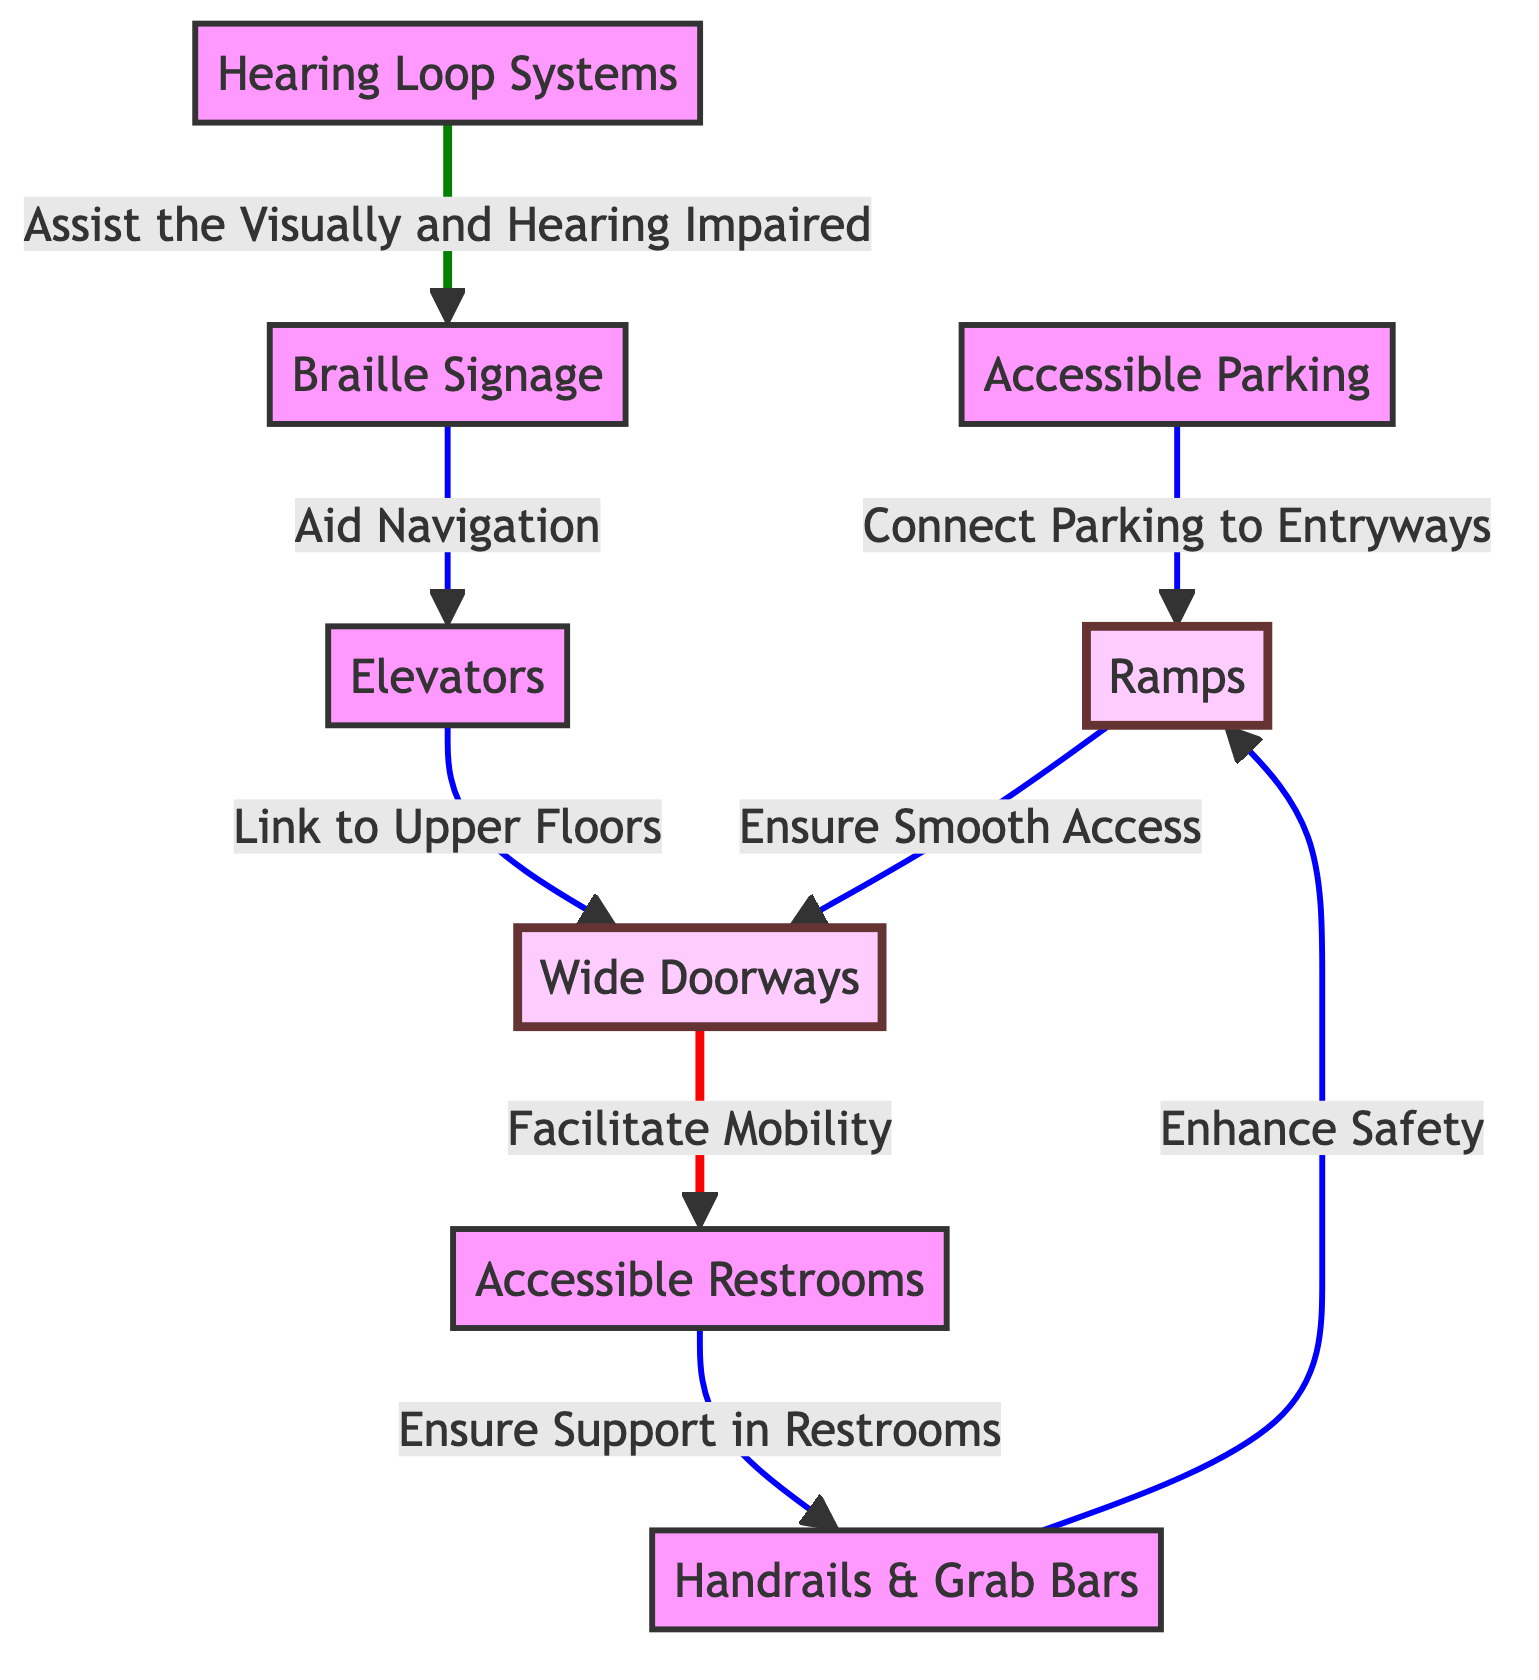What are the main components for ensuring accessibility in church facilities? The diagram shows several main components for ensuring accessibility, including ramps, elevators, wide doorways, accessible restrooms, handrails, Braille signage, hearing loop systems, and accessible parking.
Answer: Ramps, elevators, wide doorways, accessible restrooms, handrails, Braille signage, hearing loop systems, accessible parking How many main components are listed in the diagram? The diagram identifies a total of eight main components related to accessibility improvements in church facilities.
Answer: Eight Which component connects parking to entryways? The diagram indicates that accessible parking connects to entryways via ramps, facilitating access for individuals with mobility challenges.
Answer: Ramps What is the relationship between ramps and handrails? The diagram illustrates that handrails enhance safety for users of ramps, supporting a safer transition and general mobility around the church facilities.
Answer: Enhance Safety How do elevators contribute to accessibility? The diagram shows that elevators link to upper floors, providing essential access for individuals who may have difficulty using stairs, thus promoting inclusivity within the church's layout.
Answer: Link to Upper Floors Which elements aid in navigation according to the diagram? According to the diagram, Braille signage aids navigation, assisting individuals with visual impairments in finding their way around the church facilities.
Answer: Braille Signage What type of system assists those who are visually and hearing impaired? The diagram highlights that hearing loop systems are specifically designed to assist individuals who are visually and hearing impaired, enhancing their experience at the church.
Answer: Hearing Loop Systems What ensures support in restrooms according to the diagram? The diagram indicates that accessible restrooms are supported by the presence of handrails, ensuring safety and accessibility for users with disabilities.
Answer: Handrails What connects wide doorways and accessible restrooms? The diagram specifies that wide doorways serve to facilitate mobility, effectively connecting them to accessible restrooms in a way that promotes ease of movement.
Answer: Facilitate Mobility 